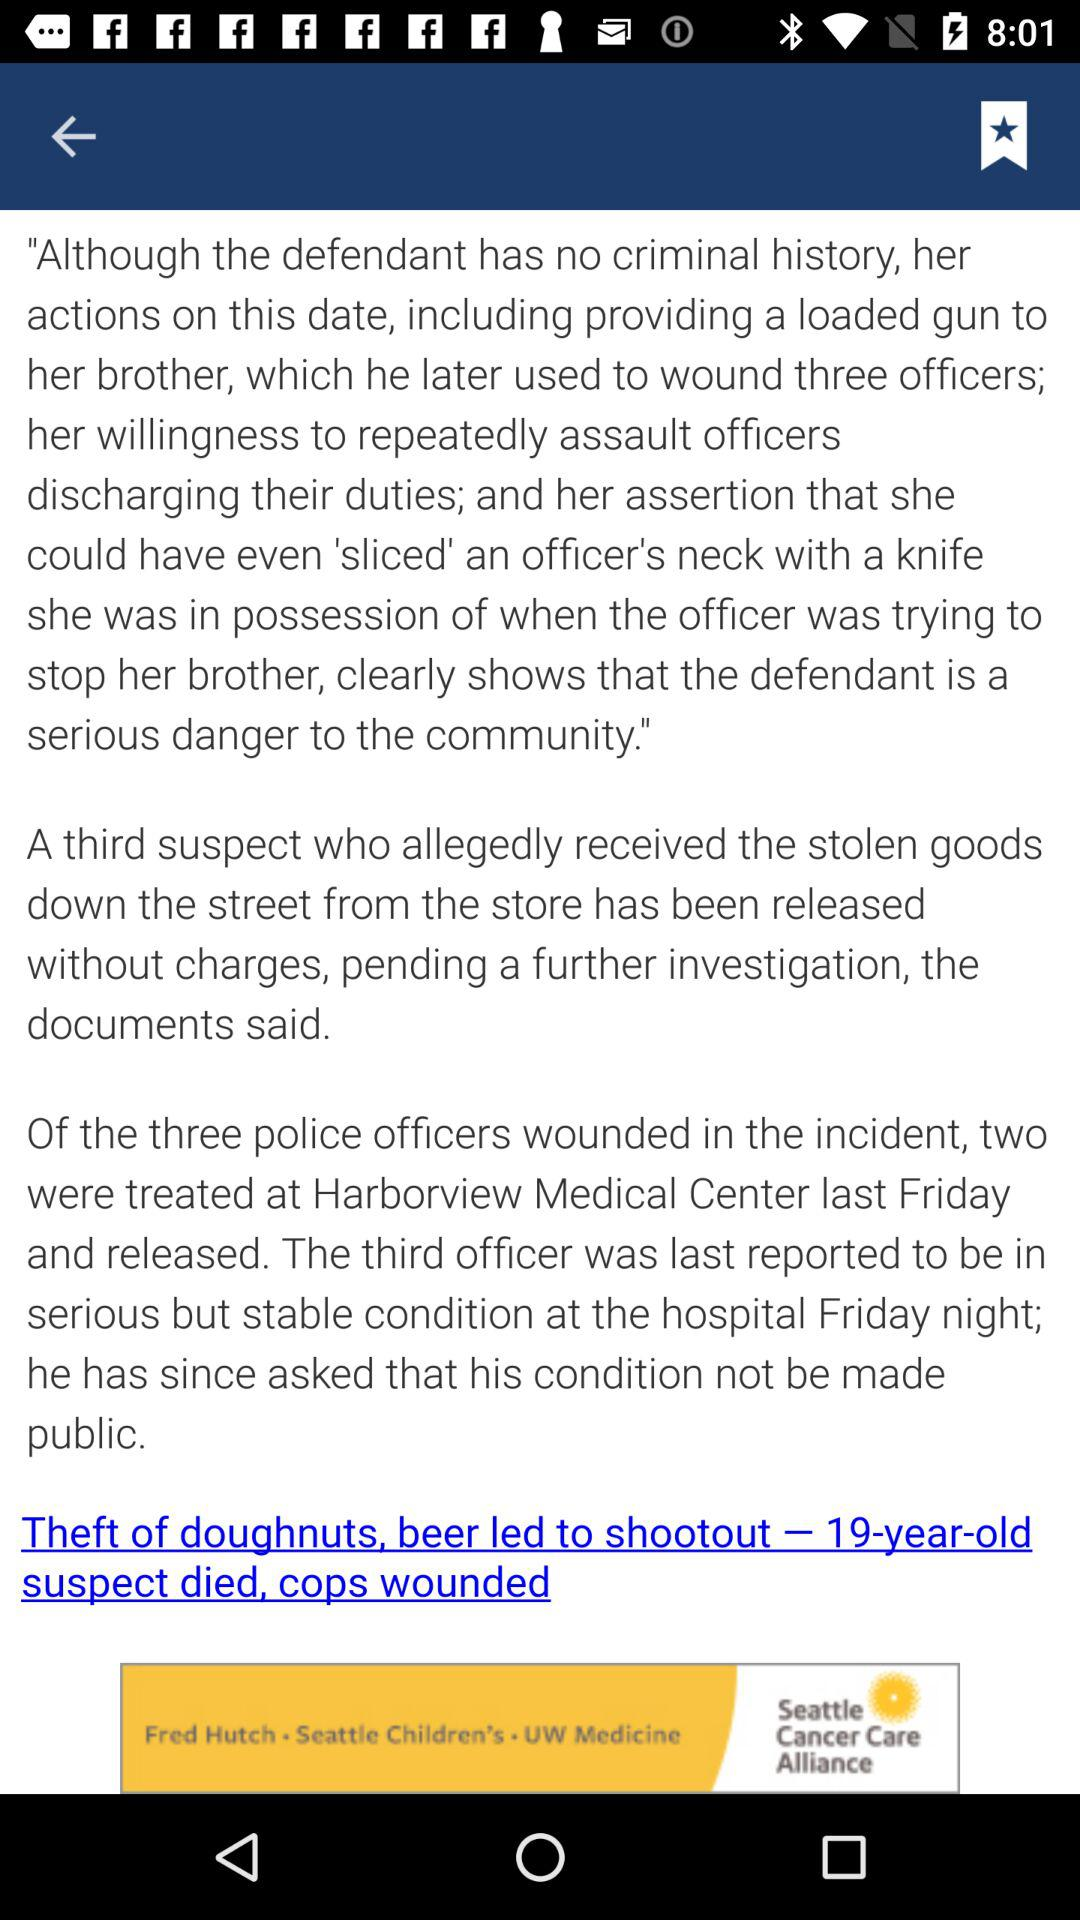What was the age of the suspect who died? The suspect was 19 years old. 